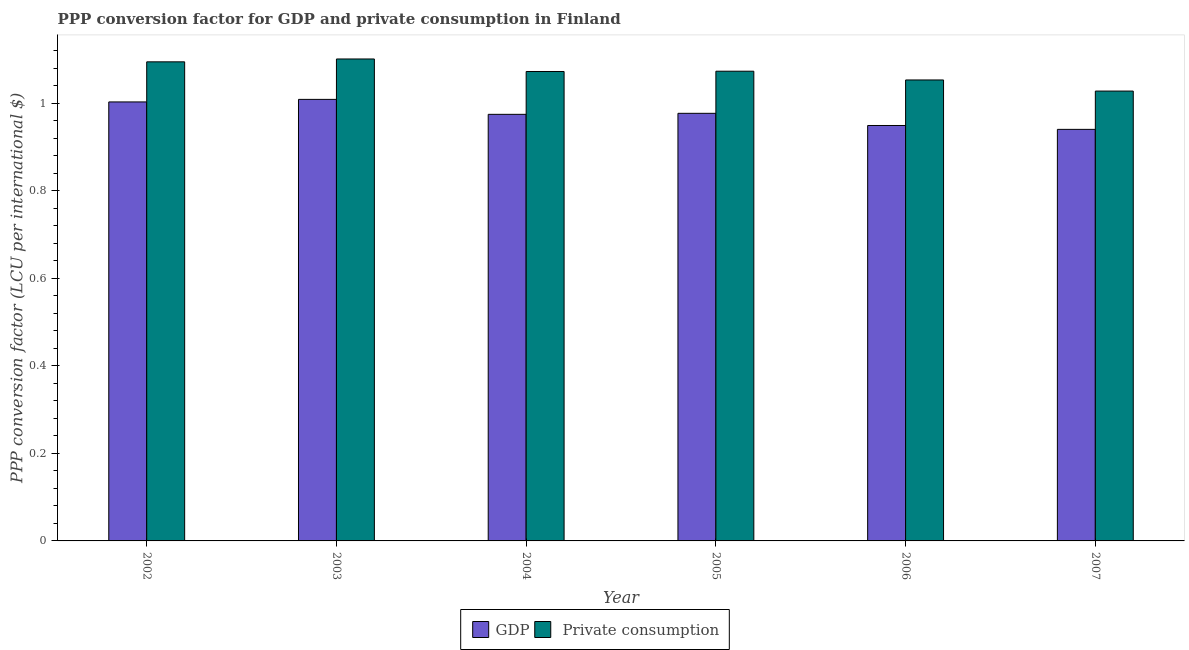How many groups of bars are there?
Ensure brevity in your answer.  6. Are the number of bars per tick equal to the number of legend labels?
Your answer should be compact. Yes. Are the number of bars on each tick of the X-axis equal?
Your answer should be very brief. Yes. In how many cases, is the number of bars for a given year not equal to the number of legend labels?
Keep it short and to the point. 0. What is the ppp conversion factor for private consumption in 2002?
Keep it short and to the point. 1.09. Across all years, what is the maximum ppp conversion factor for gdp?
Offer a very short reply. 1.01. Across all years, what is the minimum ppp conversion factor for gdp?
Keep it short and to the point. 0.94. In which year was the ppp conversion factor for private consumption minimum?
Your answer should be compact. 2007. What is the total ppp conversion factor for gdp in the graph?
Offer a terse response. 5.85. What is the difference between the ppp conversion factor for gdp in 2004 and that in 2006?
Offer a very short reply. 0.03. What is the difference between the ppp conversion factor for private consumption in 2005 and the ppp conversion factor for gdp in 2004?
Ensure brevity in your answer.  0. What is the average ppp conversion factor for gdp per year?
Your answer should be compact. 0.98. In the year 2002, what is the difference between the ppp conversion factor for gdp and ppp conversion factor for private consumption?
Your response must be concise. 0. What is the ratio of the ppp conversion factor for private consumption in 2004 to that in 2005?
Your response must be concise. 1. Is the ppp conversion factor for private consumption in 2004 less than that in 2007?
Make the answer very short. No. Is the difference between the ppp conversion factor for gdp in 2003 and 2005 greater than the difference between the ppp conversion factor for private consumption in 2003 and 2005?
Offer a very short reply. No. What is the difference between the highest and the second highest ppp conversion factor for gdp?
Your answer should be very brief. 0.01. What is the difference between the highest and the lowest ppp conversion factor for gdp?
Provide a succinct answer. 0.07. In how many years, is the ppp conversion factor for private consumption greater than the average ppp conversion factor for private consumption taken over all years?
Make the answer very short. 4. Is the sum of the ppp conversion factor for private consumption in 2004 and 2005 greater than the maximum ppp conversion factor for gdp across all years?
Your answer should be compact. Yes. What does the 1st bar from the left in 2005 represents?
Your answer should be compact. GDP. What does the 1st bar from the right in 2002 represents?
Provide a succinct answer.  Private consumption. How many bars are there?
Give a very brief answer. 12. Are all the bars in the graph horizontal?
Make the answer very short. No. How many years are there in the graph?
Provide a succinct answer. 6. What is the difference between two consecutive major ticks on the Y-axis?
Your answer should be very brief. 0.2. Does the graph contain any zero values?
Keep it short and to the point. No. Does the graph contain grids?
Ensure brevity in your answer.  No. What is the title of the graph?
Offer a very short reply. PPP conversion factor for GDP and private consumption in Finland. What is the label or title of the Y-axis?
Give a very brief answer. PPP conversion factor (LCU per international $). What is the PPP conversion factor (LCU per international $) of GDP in 2002?
Give a very brief answer. 1. What is the PPP conversion factor (LCU per international $) of  Private consumption in 2002?
Keep it short and to the point. 1.09. What is the PPP conversion factor (LCU per international $) in GDP in 2003?
Your response must be concise. 1.01. What is the PPP conversion factor (LCU per international $) in  Private consumption in 2003?
Your answer should be compact. 1.1. What is the PPP conversion factor (LCU per international $) in GDP in 2004?
Provide a short and direct response. 0.97. What is the PPP conversion factor (LCU per international $) of  Private consumption in 2004?
Your answer should be compact. 1.07. What is the PPP conversion factor (LCU per international $) in GDP in 2005?
Your answer should be compact. 0.98. What is the PPP conversion factor (LCU per international $) in  Private consumption in 2005?
Ensure brevity in your answer.  1.07. What is the PPP conversion factor (LCU per international $) of GDP in 2006?
Your answer should be compact. 0.95. What is the PPP conversion factor (LCU per international $) in  Private consumption in 2006?
Offer a terse response. 1.05. What is the PPP conversion factor (LCU per international $) of GDP in 2007?
Your response must be concise. 0.94. What is the PPP conversion factor (LCU per international $) in  Private consumption in 2007?
Provide a succinct answer. 1.03. Across all years, what is the maximum PPP conversion factor (LCU per international $) in GDP?
Your response must be concise. 1.01. Across all years, what is the maximum PPP conversion factor (LCU per international $) of  Private consumption?
Provide a succinct answer. 1.1. Across all years, what is the minimum PPP conversion factor (LCU per international $) of GDP?
Offer a terse response. 0.94. Across all years, what is the minimum PPP conversion factor (LCU per international $) in  Private consumption?
Offer a very short reply. 1.03. What is the total PPP conversion factor (LCU per international $) in GDP in the graph?
Your answer should be compact. 5.85. What is the total PPP conversion factor (LCU per international $) in  Private consumption in the graph?
Offer a terse response. 6.42. What is the difference between the PPP conversion factor (LCU per international $) in GDP in 2002 and that in 2003?
Your response must be concise. -0.01. What is the difference between the PPP conversion factor (LCU per international $) of  Private consumption in 2002 and that in 2003?
Give a very brief answer. -0.01. What is the difference between the PPP conversion factor (LCU per international $) in GDP in 2002 and that in 2004?
Your answer should be very brief. 0.03. What is the difference between the PPP conversion factor (LCU per international $) in  Private consumption in 2002 and that in 2004?
Offer a terse response. 0.02. What is the difference between the PPP conversion factor (LCU per international $) in GDP in 2002 and that in 2005?
Your response must be concise. 0.03. What is the difference between the PPP conversion factor (LCU per international $) of  Private consumption in 2002 and that in 2005?
Provide a succinct answer. 0.02. What is the difference between the PPP conversion factor (LCU per international $) of GDP in 2002 and that in 2006?
Provide a succinct answer. 0.05. What is the difference between the PPP conversion factor (LCU per international $) in  Private consumption in 2002 and that in 2006?
Offer a terse response. 0.04. What is the difference between the PPP conversion factor (LCU per international $) in GDP in 2002 and that in 2007?
Ensure brevity in your answer.  0.06. What is the difference between the PPP conversion factor (LCU per international $) of  Private consumption in 2002 and that in 2007?
Make the answer very short. 0.07. What is the difference between the PPP conversion factor (LCU per international $) of GDP in 2003 and that in 2004?
Ensure brevity in your answer.  0.03. What is the difference between the PPP conversion factor (LCU per international $) of  Private consumption in 2003 and that in 2004?
Offer a very short reply. 0.03. What is the difference between the PPP conversion factor (LCU per international $) of GDP in 2003 and that in 2005?
Offer a terse response. 0.03. What is the difference between the PPP conversion factor (LCU per international $) of  Private consumption in 2003 and that in 2005?
Keep it short and to the point. 0.03. What is the difference between the PPP conversion factor (LCU per international $) in GDP in 2003 and that in 2006?
Provide a short and direct response. 0.06. What is the difference between the PPP conversion factor (LCU per international $) of  Private consumption in 2003 and that in 2006?
Your response must be concise. 0.05. What is the difference between the PPP conversion factor (LCU per international $) in GDP in 2003 and that in 2007?
Your answer should be very brief. 0.07. What is the difference between the PPP conversion factor (LCU per international $) in  Private consumption in 2003 and that in 2007?
Provide a succinct answer. 0.07. What is the difference between the PPP conversion factor (LCU per international $) in GDP in 2004 and that in 2005?
Make the answer very short. -0. What is the difference between the PPP conversion factor (LCU per international $) in  Private consumption in 2004 and that in 2005?
Keep it short and to the point. -0. What is the difference between the PPP conversion factor (LCU per international $) of GDP in 2004 and that in 2006?
Ensure brevity in your answer.  0.03. What is the difference between the PPP conversion factor (LCU per international $) of  Private consumption in 2004 and that in 2006?
Ensure brevity in your answer.  0.02. What is the difference between the PPP conversion factor (LCU per international $) in GDP in 2004 and that in 2007?
Your response must be concise. 0.03. What is the difference between the PPP conversion factor (LCU per international $) in  Private consumption in 2004 and that in 2007?
Keep it short and to the point. 0.04. What is the difference between the PPP conversion factor (LCU per international $) in GDP in 2005 and that in 2006?
Your response must be concise. 0.03. What is the difference between the PPP conversion factor (LCU per international $) of  Private consumption in 2005 and that in 2006?
Your answer should be compact. 0.02. What is the difference between the PPP conversion factor (LCU per international $) of GDP in 2005 and that in 2007?
Your response must be concise. 0.04. What is the difference between the PPP conversion factor (LCU per international $) in  Private consumption in 2005 and that in 2007?
Your answer should be compact. 0.05. What is the difference between the PPP conversion factor (LCU per international $) of GDP in 2006 and that in 2007?
Offer a very short reply. 0.01. What is the difference between the PPP conversion factor (LCU per international $) of  Private consumption in 2006 and that in 2007?
Provide a succinct answer. 0.03. What is the difference between the PPP conversion factor (LCU per international $) of GDP in 2002 and the PPP conversion factor (LCU per international $) of  Private consumption in 2003?
Your response must be concise. -0.1. What is the difference between the PPP conversion factor (LCU per international $) of GDP in 2002 and the PPP conversion factor (LCU per international $) of  Private consumption in 2004?
Ensure brevity in your answer.  -0.07. What is the difference between the PPP conversion factor (LCU per international $) in GDP in 2002 and the PPP conversion factor (LCU per international $) in  Private consumption in 2005?
Offer a very short reply. -0.07. What is the difference between the PPP conversion factor (LCU per international $) of GDP in 2002 and the PPP conversion factor (LCU per international $) of  Private consumption in 2006?
Offer a very short reply. -0.05. What is the difference between the PPP conversion factor (LCU per international $) in GDP in 2002 and the PPP conversion factor (LCU per international $) in  Private consumption in 2007?
Offer a very short reply. -0.02. What is the difference between the PPP conversion factor (LCU per international $) in GDP in 2003 and the PPP conversion factor (LCU per international $) in  Private consumption in 2004?
Your answer should be very brief. -0.06. What is the difference between the PPP conversion factor (LCU per international $) in GDP in 2003 and the PPP conversion factor (LCU per international $) in  Private consumption in 2005?
Your answer should be compact. -0.06. What is the difference between the PPP conversion factor (LCU per international $) in GDP in 2003 and the PPP conversion factor (LCU per international $) in  Private consumption in 2006?
Your answer should be compact. -0.04. What is the difference between the PPP conversion factor (LCU per international $) of GDP in 2003 and the PPP conversion factor (LCU per international $) of  Private consumption in 2007?
Give a very brief answer. -0.02. What is the difference between the PPP conversion factor (LCU per international $) of GDP in 2004 and the PPP conversion factor (LCU per international $) of  Private consumption in 2005?
Provide a short and direct response. -0.1. What is the difference between the PPP conversion factor (LCU per international $) of GDP in 2004 and the PPP conversion factor (LCU per international $) of  Private consumption in 2006?
Your response must be concise. -0.08. What is the difference between the PPP conversion factor (LCU per international $) of GDP in 2004 and the PPP conversion factor (LCU per international $) of  Private consumption in 2007?
Provide a short and direct response. -0.05. What is the difference between the PPP conversion factor (LCU per international $) of GDP in 2005 and the PPP conversion factor (LCU per international $) of  Private consumption in 2006?
Your answer should be very brief. -0.08. What is the difference between the PPP conversion factor (LCU per international $) in GDP in 2005 and the PPP conversion factor (LCU per international $) in  Private consumption in 2007?
Ensure brevity in your answer.  -0.05. What is the difference between the PPP conversion factor (LCU per international $) of GDP in 2006 and the PPP conversion factor (LCU per international $) of  Private consumption in 2007?
Your answer should be compact. -0.08. What is the average PPP conversion factor (LCU per international $) of GDP per year?
Provide a short and direct response. 0.98. What is the average PPP conversion factor (LCU per international $) of  Private consumption per year?
Provide a short and direct response. 1.07. In the year 2002, what is the difference between the PPP conversion factor (LCU per international $) of GDP and PPP conversion factor (LCU per international $) of  Private consumption?
Offer a very short reply. -0.09. In the year 2003, what is the difference between the PPP conversion factor (LCU per international $) in GDP and PPP conversion factor (LCU per international $) in  Private consumption?
Your answer should be compact. -0.09. In the year 2004, what is the difference between the PPP conversion factor (LCU per international $) of GDP and PPP conversion factor (LCU per international $) of  Private consumption?
Make the answer very short. -0.1. In the year 2005, what is the difference between the PPP conversion factor (LCU per international $) of GDP and PPP conversion factor (LCU per international $) of  Private consumption?
Make the answer very short. -0.1. In the year 2006, what is the difference between the PPP conversion factor (LCU per international $) in GDP and PPP conversion factor (LCU per international $) in  Private consumption?
Ensure brevity in your answer.  -0.1. In the year 2007, what is the difference between the PPP conversion factor (LCU per international $) of GDP and PPP conversion factor (LCU per international $) of  Private consumption?
Give a very brief answer. -0.09. What is the ratio of the PPP conversion factor (LCU per international $) in  Private consumption in 2002 to that in 2003?
Keep it short and to the point. 0.99. What is the ratio of the PPP conversion factor (LCU per international $) of GDP in 2002 to that in 2004?
Make the answer very short. 1.03. What is the ratio of the PPP conversion factor (LCU per international $) of  Private consumption in 2002 to that in 2004?
Offer a terse response. 1.02. What is the ratio of the PPP conversion factor (LCU per international $) of GDP in 2002 to that in 2005?
Your answer should be compact. 1.03. What is the ratio of the PPP conversion factor (LCU per international $) in GDP in 2002 to that in 2006?
Your answer should be compact. 1.06. What is the ratio of the PPP conversion factor (LCU per international $) in  Private consumption in 2002 to that in 2006?
Your response must be concise. 1.04. What is the ratio of the PPP conversion factor (LCU per international $) in GDP in 2002 to that in 2007?
Ensure brevity in your answer.  1.07. What is the ratio of the PPP conversion factor (LCU per international $) in  Private consumption in 2002 to that in 2007?
Offer a terse response. 1.06. What is the ratio of the PPP conversion factor (LCU per international $) in GDP in 2003 to that in 2004?
Provide a succinct answer. 1.04. What is the ratio of the PPP conversion factor (LCU per international $) of  Private consumption in 2003 to that in 2004?
Make the answer very short. 1.03. What is the ratio of the PPP conversion factor (LCU per international $) of GDP in 2003 to that in 2005?
Give a very brief answer. 1.03. What is the ratio of the PPP conversion factor (LCU per international $) in  Private consumption in 2003 to that in 2005?
Make the answer very short. 1.03. What is the ratio of the PPP conversion factor (LCU per international $) of GDP in 2003 to that in 2006?
Provide a short and direct response. 1.06. What is the ratio of the PPP conversion factor (LCU per international $) in  Private consumption in 2003 to that in 2006?
Offer a terse response. 1.05. What is the ratio of the PPP conversion factor (LCU per international $) in GDP in 2003 to that in 2007?
Keep it short and to the point. 1.07. What is the ratio of the PPP conversion factor (LCU per international $) of  Private consumption in 2003 to that in 2007?
Offer a very short reply. 1.07. What is the ratio of the PPP conversion factor (LCU per international $) in GDP in 2004 to that in 2005?
Ensure brevity in your answer.  1. What is the ratio of the PPP conversion factor (LCU per international $) in  Private consumption in 2004 to that in 2005?
Provide a short and direct response. 1. What is the ratio of the PPP conversion factor (LCU per international $) of GDP in 2004 to that in 2006?
Keep it short and to the point. 1.03. What is the ratio of the PPP conversion factor (LCU per international $) in  Private consumption in 2004 to that in 2006?
Your response must be concise. 1.02. What is the ratio of the PPP conversion factor (LCU per international $) of GDP in 2004 to that in 2007?
Ensure brevity in your answer.  1.04. What is the ratio of the PPP conversion factor (LCU per international $) in  Private consumption in 2004 to that in 2007?
Provide a short and direct response. 1.04. What is the ratio of the PPP conversion factor (LCU per international $) in GDP in 2005 to that in 2006?
Offer a very short reply. 1.03. What is the ratio of the PPP conversion factor (LCU per international $) of  Private consumption in 2005 to that in 2006?
Ensure brevity in your answer.  1.02. What is the ratio of the PPP conversion factor (LCU per international $) in GDP in 2005 to that in 2007?
Provide a short and direct response. 1.04. What is the ratio of the PPP conversion factor (LCU per international $) of  Private consumption in 2005 to that in 2007?
Provide a short and direct response. 1.04. What is the ratio of the PPP conversion factor (LCU per international $) in GDP in 2006 to that in 2007?
Give a very brief answer. 1.01. What is the ratio of the PPP conversion factor (LCU per international $) of  Private consumption in 2006 to that in 2007?
Your answer should be compact. 1.02. What is the difference between the highest and the second highest PPP conversion factor (LCU per international $) in GDP?
Your answer should be very brief. 0.01. What is the difference between the highest and the second highest PPP conversion factor (LCU per international $) in  Private consumption?
Give a very brief answer. 0.01. What is the difference between the highest and the lowest PPP conversion factor (LCU per international $) in GDP?
Offer a very short reply. 0.07. What is the difference between the highest and the lowest PPP conversion factor (LCU per international $) of  Private consumption?
Make the answer very short. 0.07. 